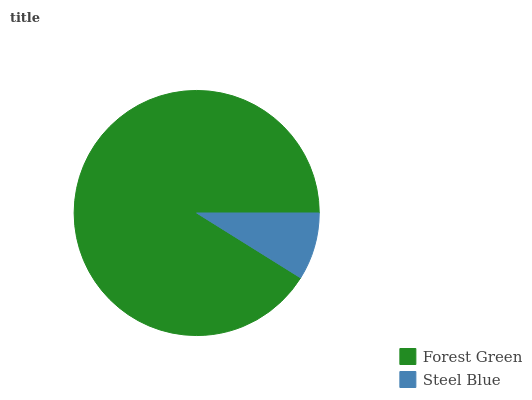Is Steel Blue the minimum?
Answer yes or no. Yes. Is Forest Green the maximum?
Answer yes or no. Yes. Is Steel Blue the maximum?
Answer yes or no. No. Is Forest Green greater than Steel Blue?
Answer yes or no. Yes. Is Steel Blue less than Forest Green?
Answer yes or no. Yes. Is Steel Blue greater than Forest Green?
Answer yes or no. No. Is Forest Green less than Steel Blue?
Answer yes or no. No. Is Forest Green the high median?
Answer yes or no. Yes. Is Steel Blue the low median?
Answer yes or no. Yes. Is Steel Blue the high median?
Answer yes or no. No. Is Forest Green the low median?
Answer yes or no. No. 